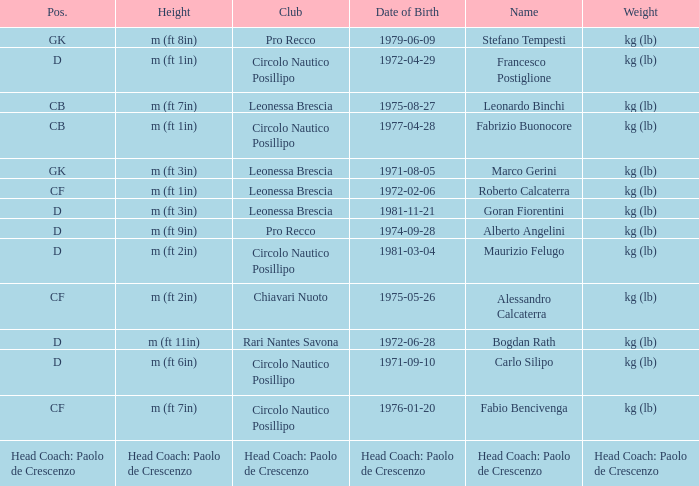What is the name of the player from club Circolo Nautico Posillipo and a position of D? Francesco Postiglione, Maurizio Felugo, Carlo Silipo. 